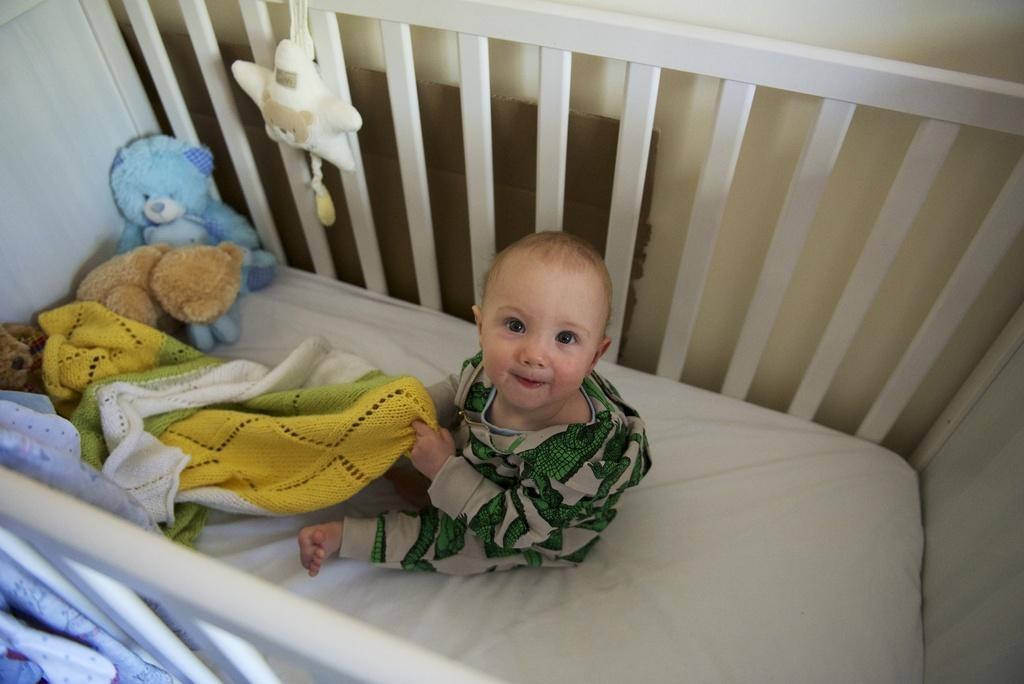What is the main subject of the image? The main subject of the image is a kid. Where is the kid located in the image? The kid is sitting on a bed. What is the kid holding in his hand? The kid is holding a towel in his hand. What type of vest can be seen on the kid in the image? There is no vest visible on the kid in the image. Can you tell me how many cards the kid is holding in his hand? The kid is not holding any cards in his hand; he is holding a towel. 